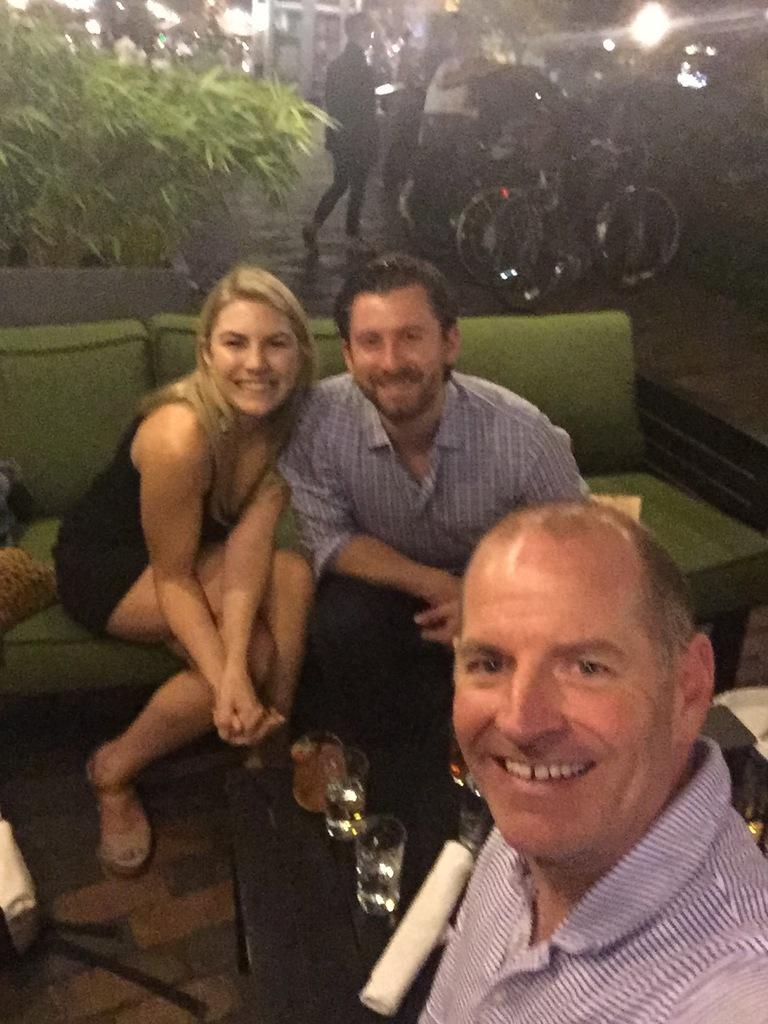How many people are in the image? There are three people in the image. What is the facial expression of the people in the image? The people are smiling. Where are two of the people sitting in the image? Two people are sitting on a couch. What is on the table in the image? There are glasses and other objects on the table. What can be seen in the background of the image? There are bicycles, people, and a plant in the background. What type of police force is present in the image? There is no police force present in the image. What color is the balloon that the people are holding in the image? There is no balloon present in the image. 